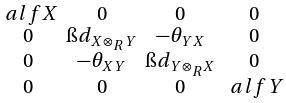Convert formula to latex. <formula><loc_0><loc_0><loc_500><loc_500>\begin{smallmatrix} \ a l f X & 0 & 0 & 0 \\ 0 & \i d _ { X \otimes _ { R } Y } & - \theta _ { Y X } & 0 \\ 0 & - \theta _ { X Y } & \i d _ { Y \otimes _ { R } X } & 0 \\ 0 & 0 & 0 & \ a l f Y \end{smallmatrix}</formula> 